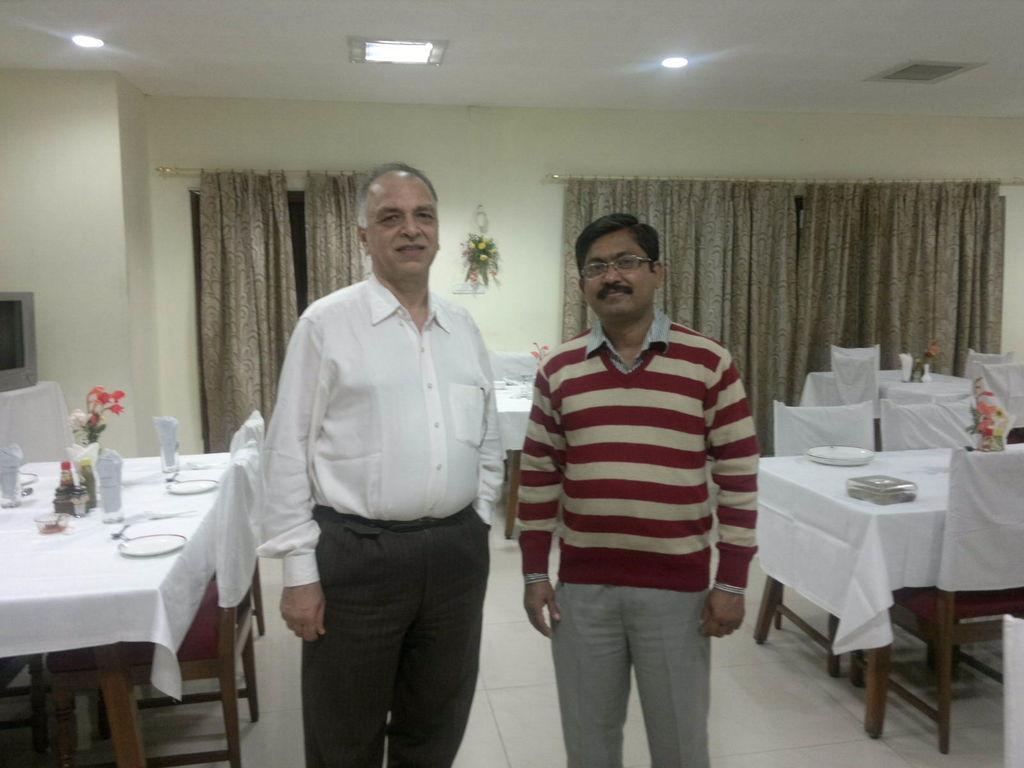What is the main subject of the image? There is a man standing in the image. Where is the man standing? The man is standing on the floor. What type of furniture can be seen in the image? There are tables and chairs visible in the image. What type of window treatment is present in the image? There are curtains in the image. What type of glove is the man wearing on his elbow in the image? There is no glove or mention of an elbow in the image; the man is simply standing on the floor. 